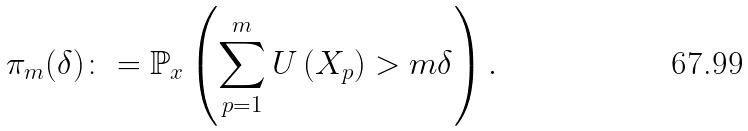<formula> <loc_0><loc_0><loc_500><loc_500>\pi _ { m } ( \delta ) \colon = \mathbb { P } _ { x } \left ( \sum _ { p = 1 } ^ { m } U \left ( X _ { p } \right ) > m \delta \right ) .</formula> 